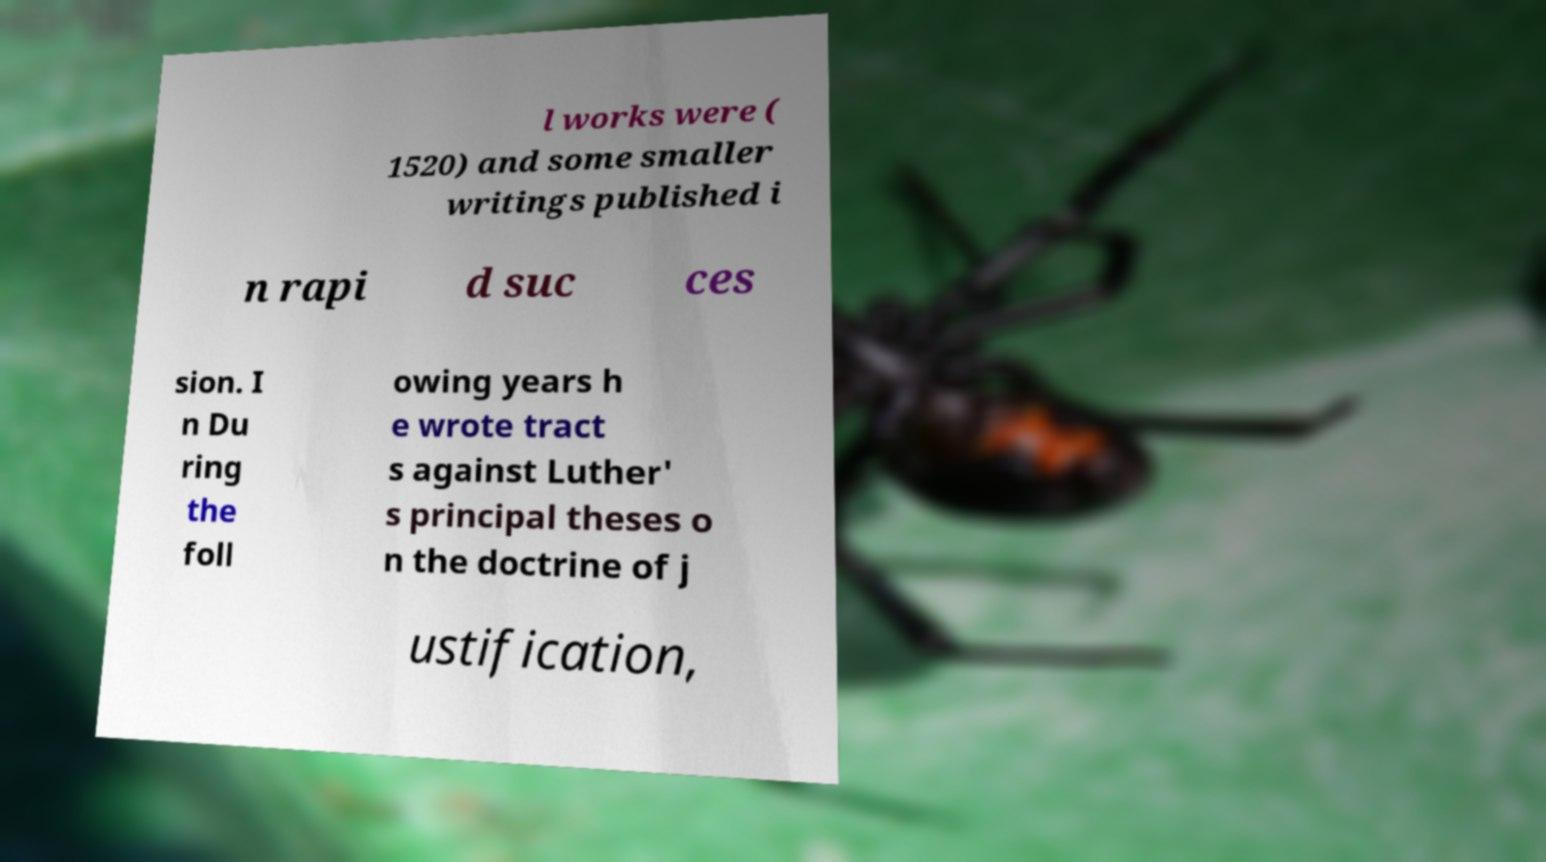Could you extract and type out the text from this image? l works were ( 1520) and some smaller writings published i n rapi d suc ces sion. I n Du ring the foll owing years h e wrote tract s against Luther' s principal theses o n the doctrine of j ustification, 